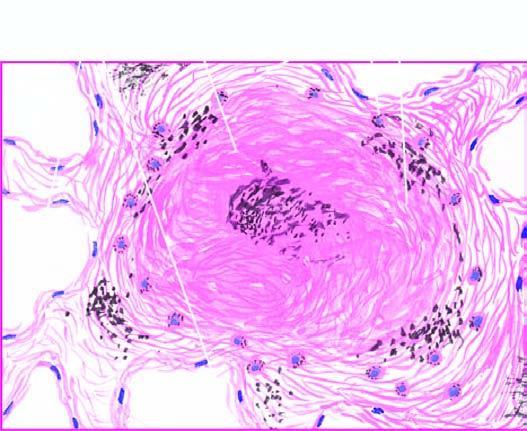does a wedge-shaped shrunken area of pale colour consist of hyaline centre surrounded by concentric layers of collagen which are further enclosed by fibroblasts and dust-laden macrophages?
Answer the question using a single word or phrase. No 